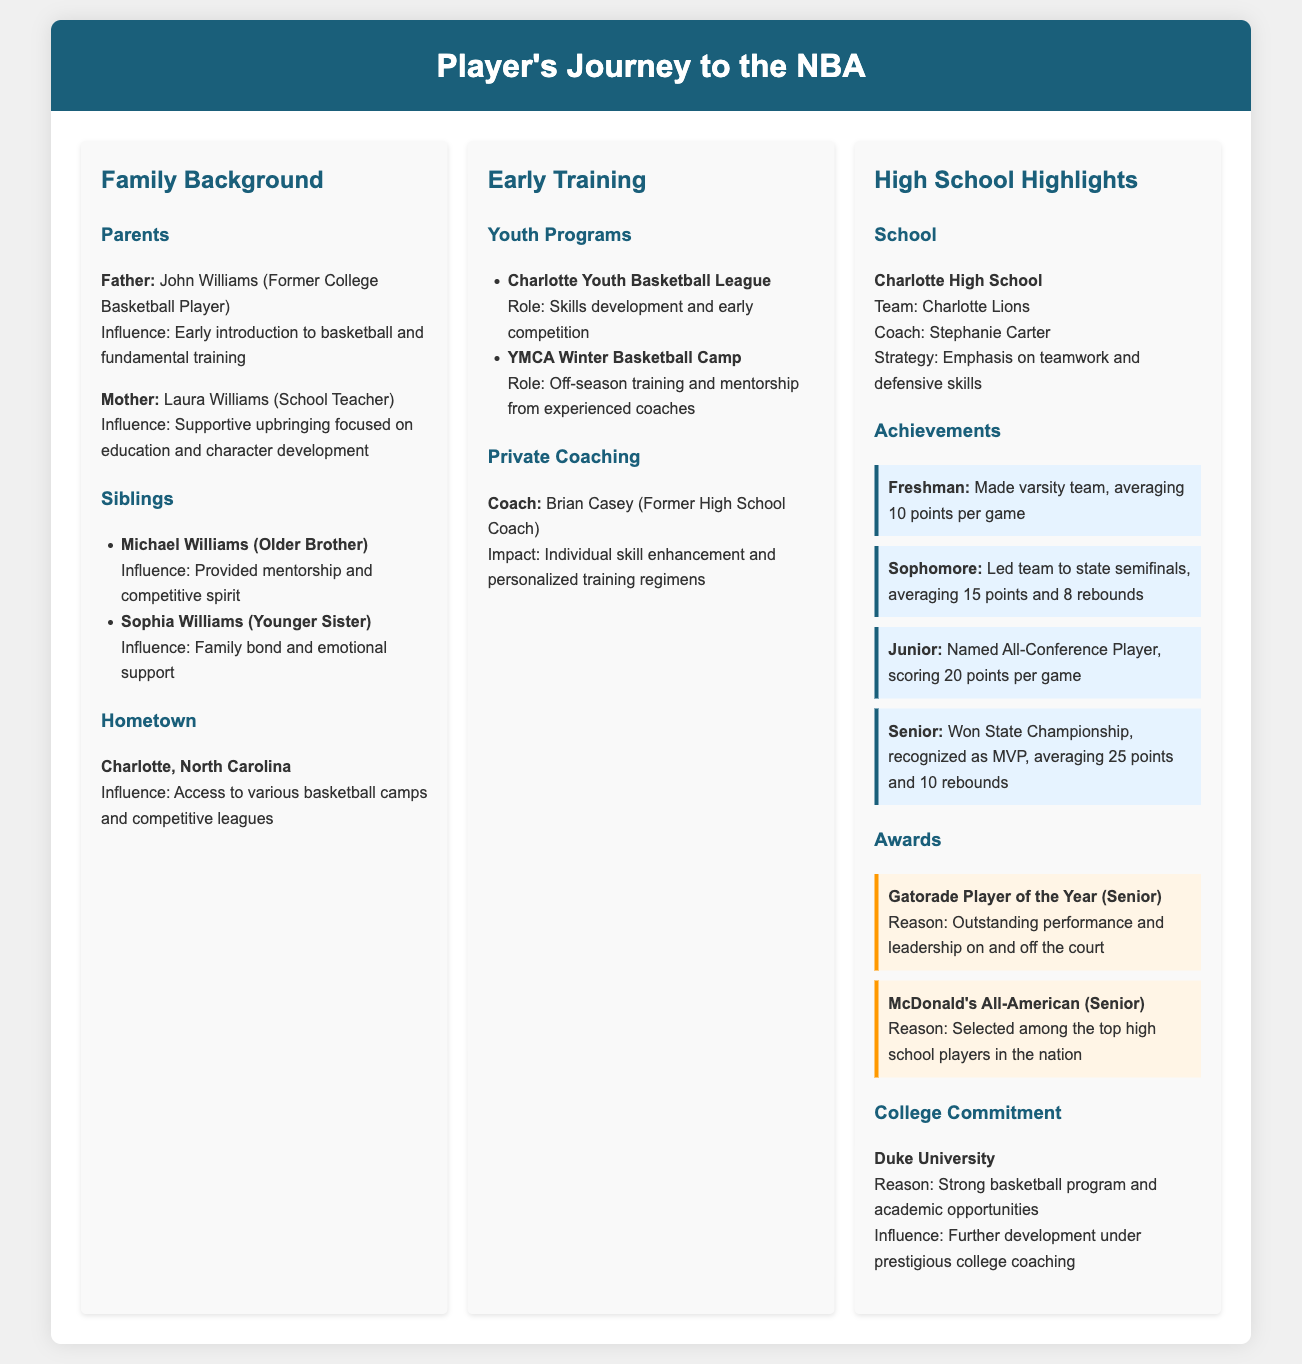What is the father's name? The father's name is explicitly mentioned in the document as John Williams.
Answer: John Williams What is the mother's occupation? The document states that the mother is a school teacher, which is her occupation.
Answer: School Teacher How many points did the player average as a senior? The document provides the specific average points per game for the senior year, which is 25.
Answer: 25 points What accolade did the player receive as a senior? The document highlights that the player won the Gatorade Player of the Year award during their senior year.
Answer: Gatorade Player of the Year Which high school did the player attend? The document clearly states that the player attended Charlotte High School.
Answer: Charlotte High School What is the name of the player's older brother? The older brother's name is given in the section about siblings, indicating that it is Michael Williams.
Answer: Michael Williams What was the player's average points per game as a junior? The document specifies that the player averaged 20 points per game during their junior year.
Answer: 20 points Which university did the player commit to? The document indicates that the player committed to Duke University for further development.
Answer: Duke University What was the coach's name at Charlotte High School? The coach's name is mentioned as Stephanie Carter in the document.
Answer: Stephanie Carter 